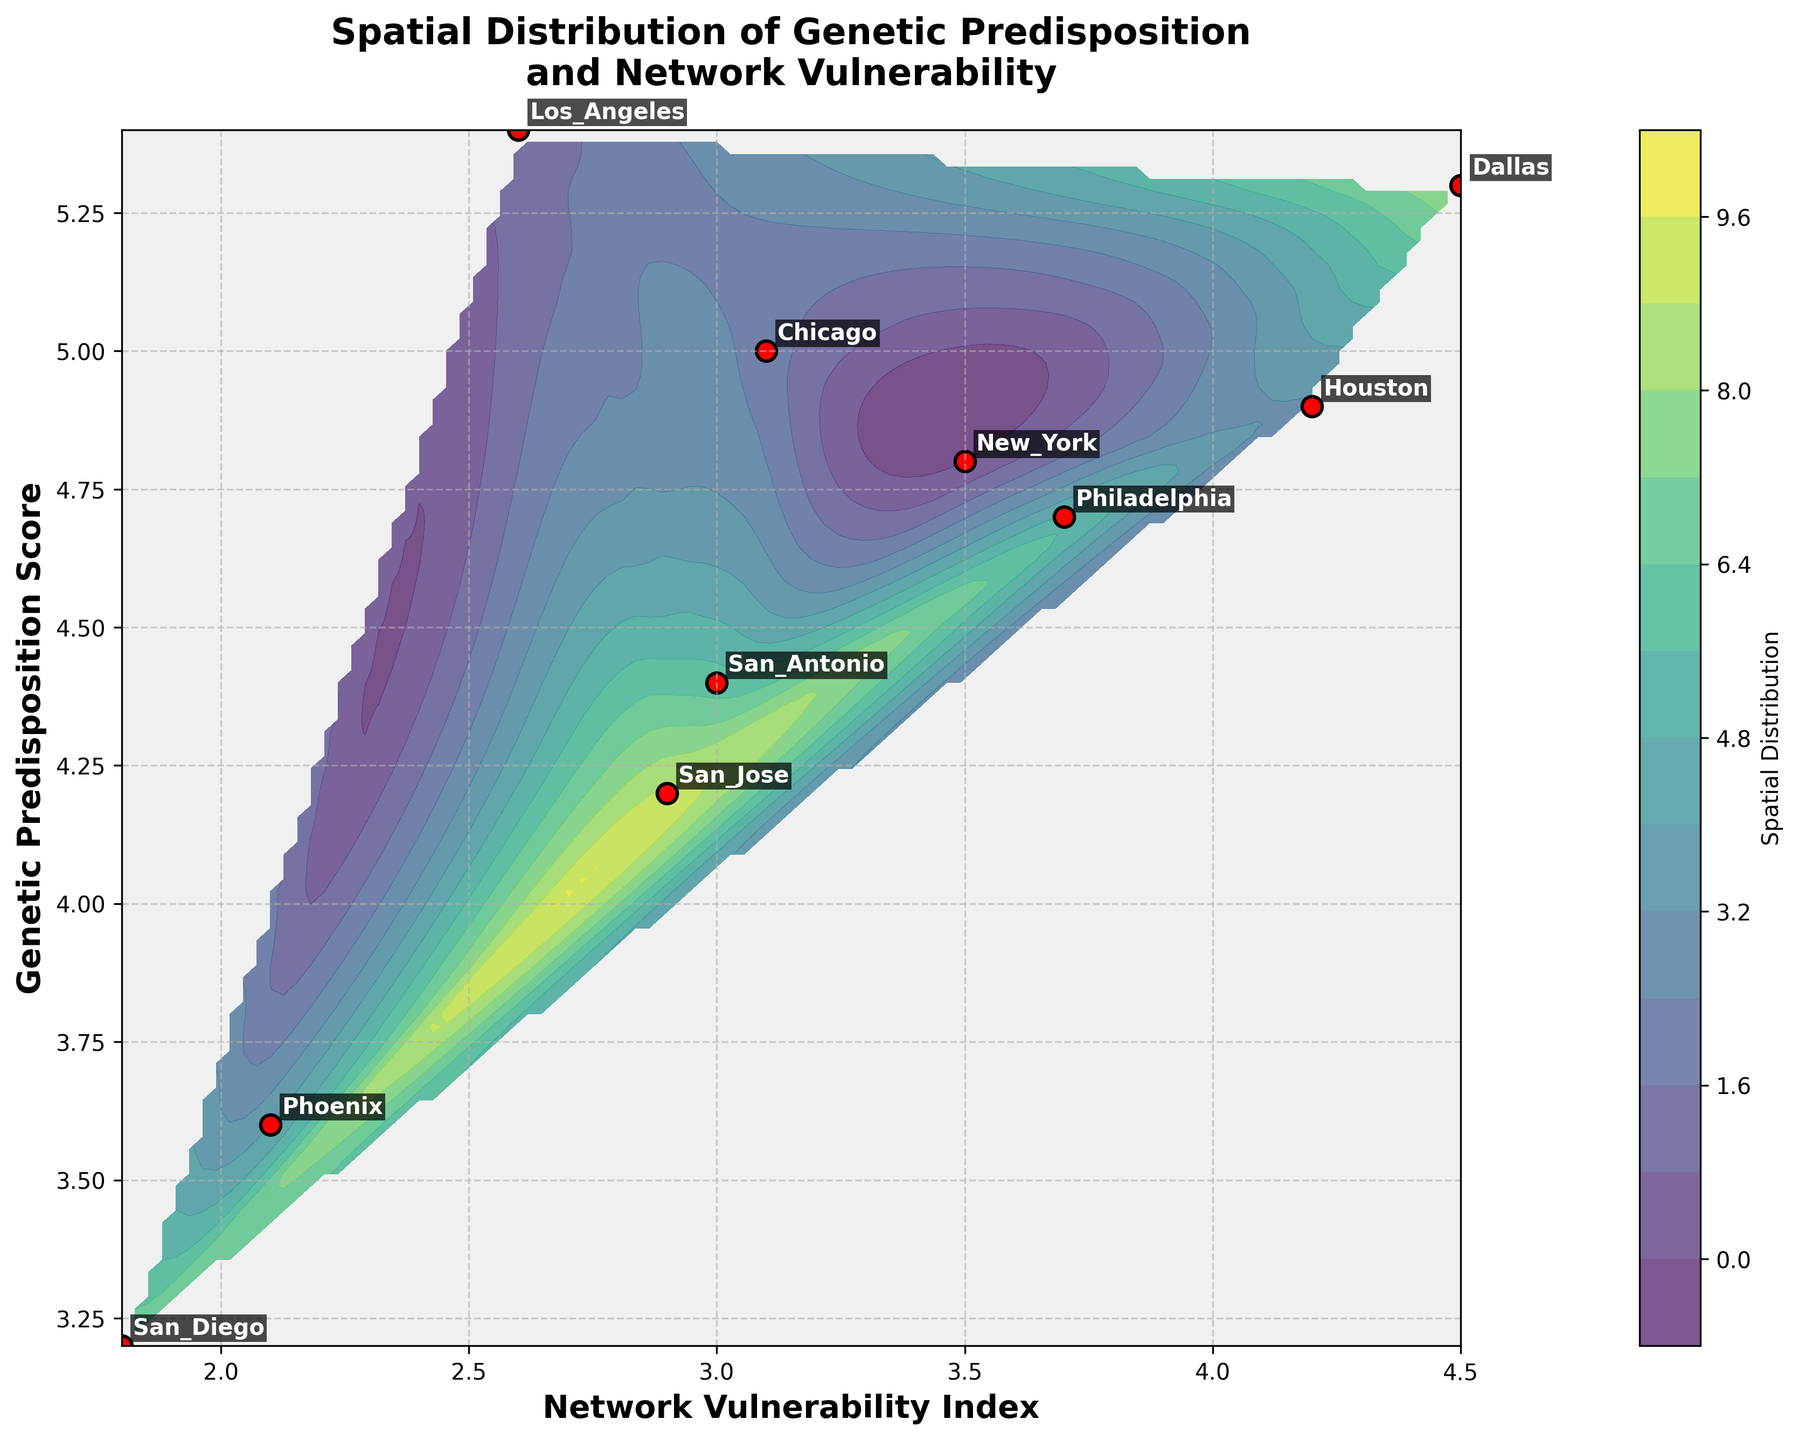What's the title of the figure? The title is displayed at the top of the figure, usually summarizing its content in a concise manner. Here, it is clearly written and easy to identify within the figure.
Answer: Spatial Distribution of Genetic Predisposition and Network Vulnerability How many locations are represented in the figure? The plot shows labeled scatter points representing different locations. By counting all the labels, we can determine the number of locations represented.
Answer: 10 Which location has the highest genetic predisposition score? By observing the y-axis, which represents Genetic Predisposition, and looking for the highest labeled point along this axis, we can identify this location.
Answer: Los_Angeles What are the values of Network Vulnerability and Genetic Predisposition for Philadelphia? Locate the label 'Philadelphia' on the plotted scatter points and reference the x and y coordinates to find the respective values.
Answer: Network Vulnerability: 3.7, Genetic Predisposition: 4.7 Which location shows the highest network vulnerability index? Examine the x-axis, which represents Network Vulnerability, and identify the scatter point with the maximum x-value. The corresponding label will tell the location.
Answer: Dallas Are there any locations with both lower network vulnerability and lower genetic predisposition? Look for scatter points that have both x and y values toward the lower ends of their respective axes. Identify the corresponding labels.
Answer: San_Diego, Phoenix What is the average network vulnerability index for all locations? Sum all the Network Vulnerability indices of the locations and divide by the number of locations to calculate the average. Calculation: (3.5 + 2.6 + 3.1 + 4.2 + 2.1 + 3.7 + 3.0 + 1.8 + 4.5 + 2.9) / 10 = 31.4 / 10
Answer: 3.14 Comparing Houston and San_Jose, which location has a higher genetic predisposition score? Locate both 'Houston' and 'San_Jose' labels on the plot, compare their positions along the y-axis which represents Genetic Predisposition.
Answer: Houston Which two locations are closest in terms of network vulnerability? Examine the x-axis values of all labeled locations and find the two closest points in terms of x-values.
Answer: Chicago and San_Antonio How does the overall spatial distribution look in terms of network vulnerability and genetic predisposition? Observe the contour lines generated in the plot, which indicate areas of similar values. A qualitative assessment can help understand the spread and concentration of the data points in the grid.
Answer: Fairly spread out with varying levels 